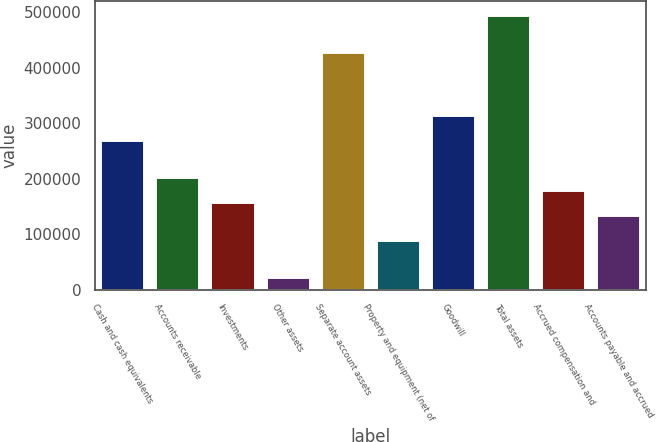Convert chart. <chart><loc_0><loc_0><loc_500><loc_500><bar_chart><fcel>Cash and cash equivalents<fcel>Accounts receivable<fcel>Investments<fcel>Other assets<fcel>Separate account assets<fcel>Property and equipment (net of<fcel>Goodwill<fcel>Total assets<fcel>Accrued compensation and<fcel>Accounts payable and accrued<nl><fcel>270313<fcel>202735<fcel>157683<fcel>22527.9<fcel>427994<fcel>90105.6<fcel>315365<fcel>495572<fcel>180209<fcel>135157<nl></chart> 